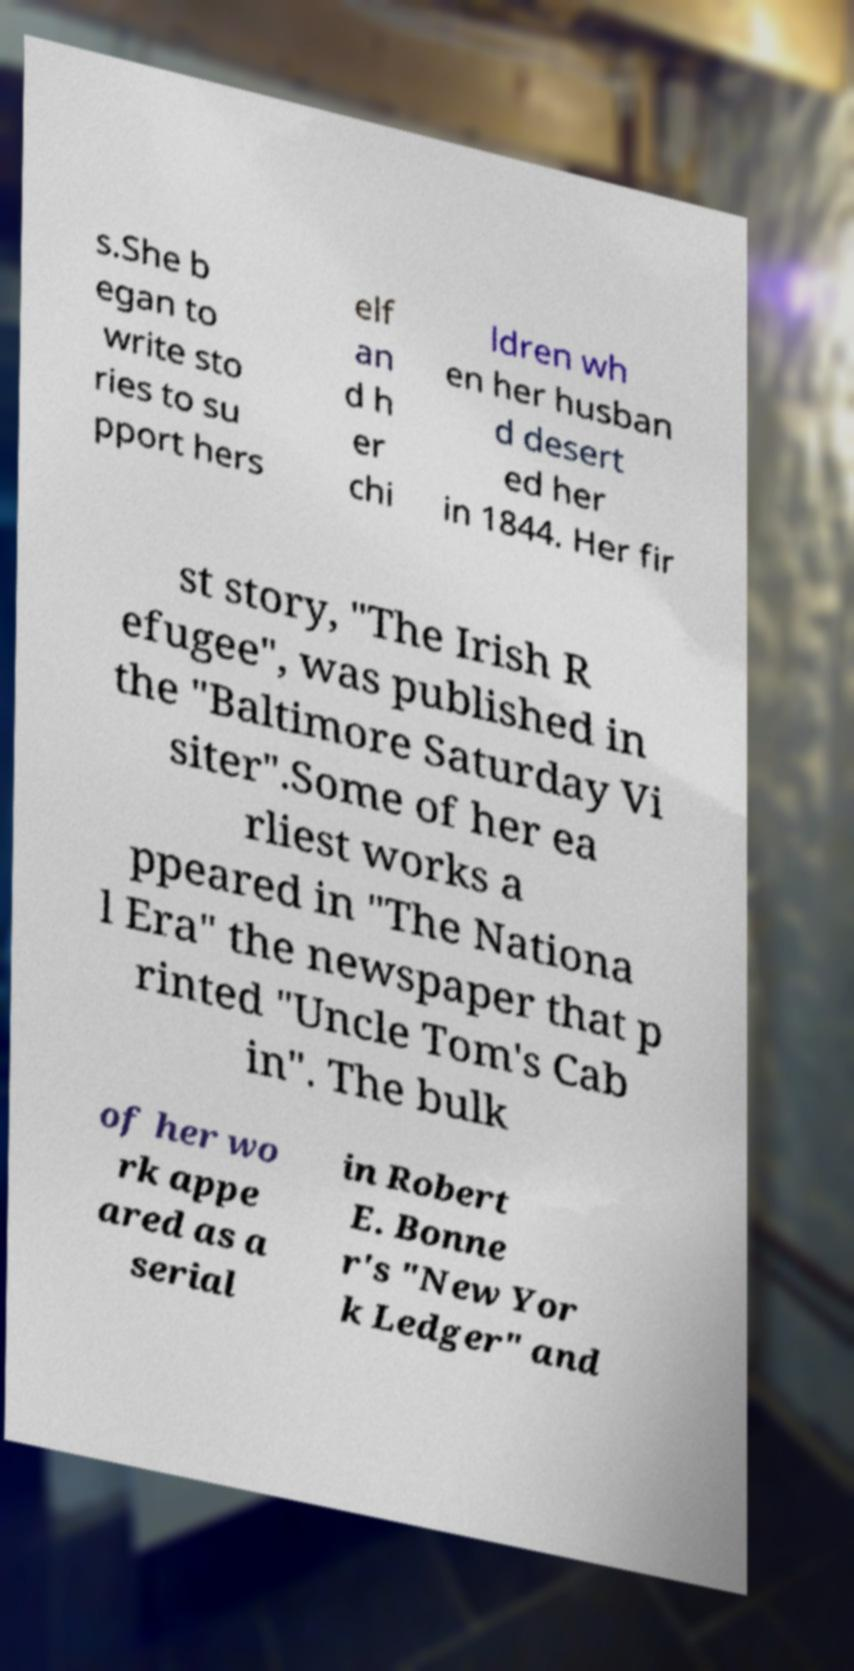There's text embedded in this image that I need extracted. Can you transcribe it verbatim? s.She b egan to write sto ries to su pport hers elf an d h er chi ldren wh en her husban d desert ed her in 1844. Her fir st story, "The Irish R efugee", was published in the "Baltimore Saturday Vi siter".Some of her ea rliest works a ppeared in "The Nationa l Era" the newspaper that p rinted "Uncle Tom's Cab in". The bulk of her wo rk appe ared as a serial in Robert E. Bonne r's "New Yor k Ledger" and 